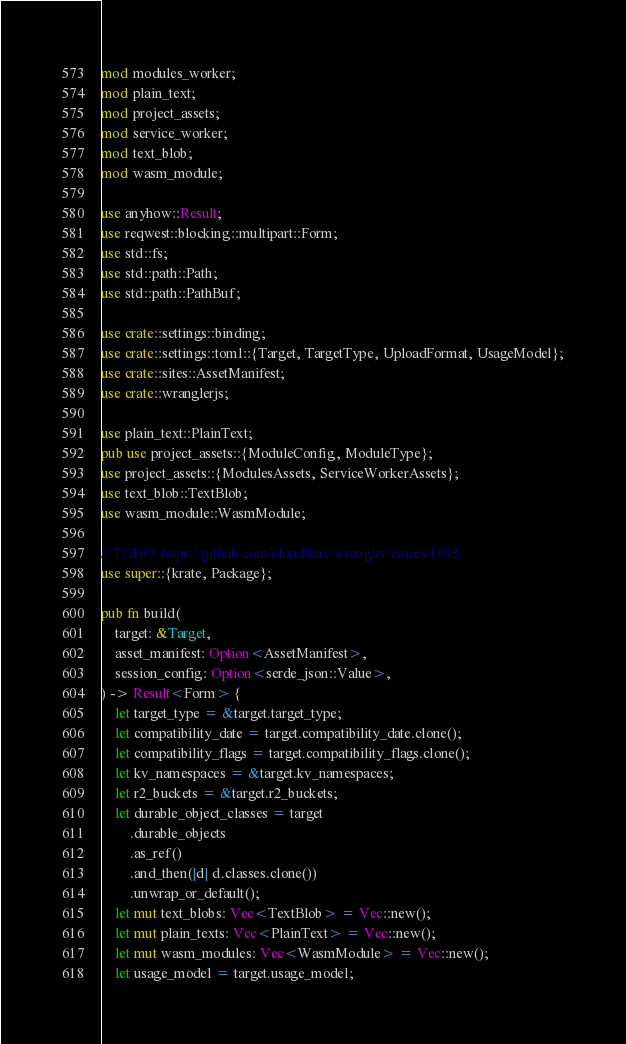Convert code to text. <code><loc_0><loc_0><loc_500><loc_500><_Rust_>mod modules_worker;
mod plain_text;
mod project_assets;
mod service_worker;
mod text_blob;
mod wasm_module;

use anyhow::Result;
use reqwest::blocking::multipart::Form;
use std::fs;
use std::path::Path;
use std::path::PathBuf;

use crate::settings::binding;
use crate::settings::toml::{Target, TargetType, UploadFormat, UsageModel};
use crate::sites::AssetManifest;
use crate::wranglerjs;

use plain_text::PlainText;
pub use project_assets::{ModuleConfig, ModuleType};
use project_assets::{ModulesAssets, ServiceWorkerAssets};
use text_blob::TextBlob;
use wasm_module::WasmModule;

// TODO: https://github.com/cloudflare/wrangler/issues/1083
use super::{krate, Package};

pub fn build(
    target: &Target,
    asset_manifest: Option<AssetManifest>,
    session_config: Option<serde_json::Value>,
) -> Result<Form> {
    let target_type = &target.target_type;
    let compatibility_date = target.compatibility_date.clone();
    let compatibility_flags = target.compatibility_flags.clone();
    let kv_namespaces = &target.kv_namespaces;
    let r2_buckets = &target.r2_buckets;
    let durable_object_classes = target
        .durable_objects
        .as_ref()
        .and_then(|d| d.classes.clone())
        .unwrap_or_default();
    let mut text_blobs: Vec<TextBlob> = Vec::new();
    let mut plain_texts: Vec<PlainText> = Vec::new();
    let mut wasm_modules: Vec<WasmModule> = Vec::new();
    let usage_model = target.usage_model;
</code> 